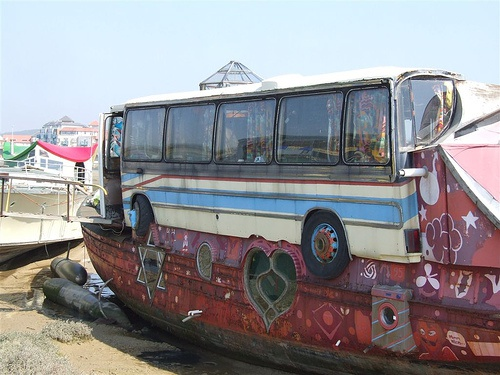Describe the objects in this image and their specific colors. I can see boat in lightblue, gray, maroon, black, and darkgray tones, bus in lightblue, gray, darkgray, and black tones, and boat in lightblue, ivory, black, darkgray, and gray tones in this image. 